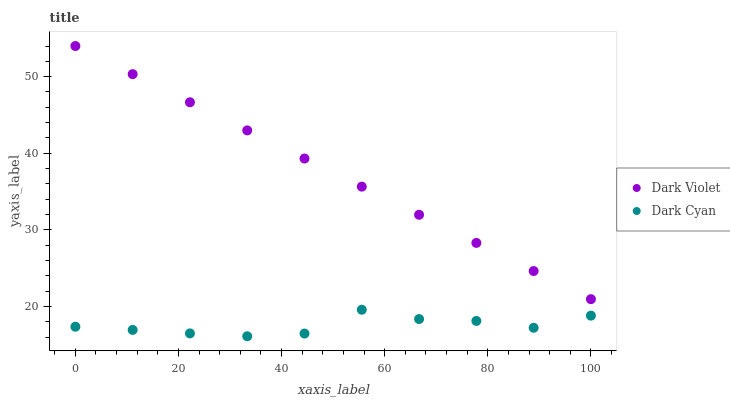Does Dark Cyan have the minimum area under the curve?
Answer yes or no. Yes. Does Dark Violet have the maximum area under the curve?
Answer yes or no. Yes. Does Dark Violet have the minimum area under the curve?
Answer yes or no. No. Is Dark Violet the smoothest?
Answer yes or no. Yes. Is Dark Cyan the roughest?
Answer yes or no. Yes. Is Dark Violet the roughest?
Answer yes or no. No. Does Dark Cyan have the lowest value?
Answer yes or no. Yes. Does Dark Violet have the lowest value?
Answer yes or no. No. Does Dark Violet have the highest value?
Answer yes or no. Yes. Is Dark Cyan less than Dark Violet?
Answer yes or no. Yes. Is Dark Violet greater than Dark Cyan?
Answer yes or no. Yes. Does Dark Cyan intersect Dark Violet?
Answer yes or no. No. 